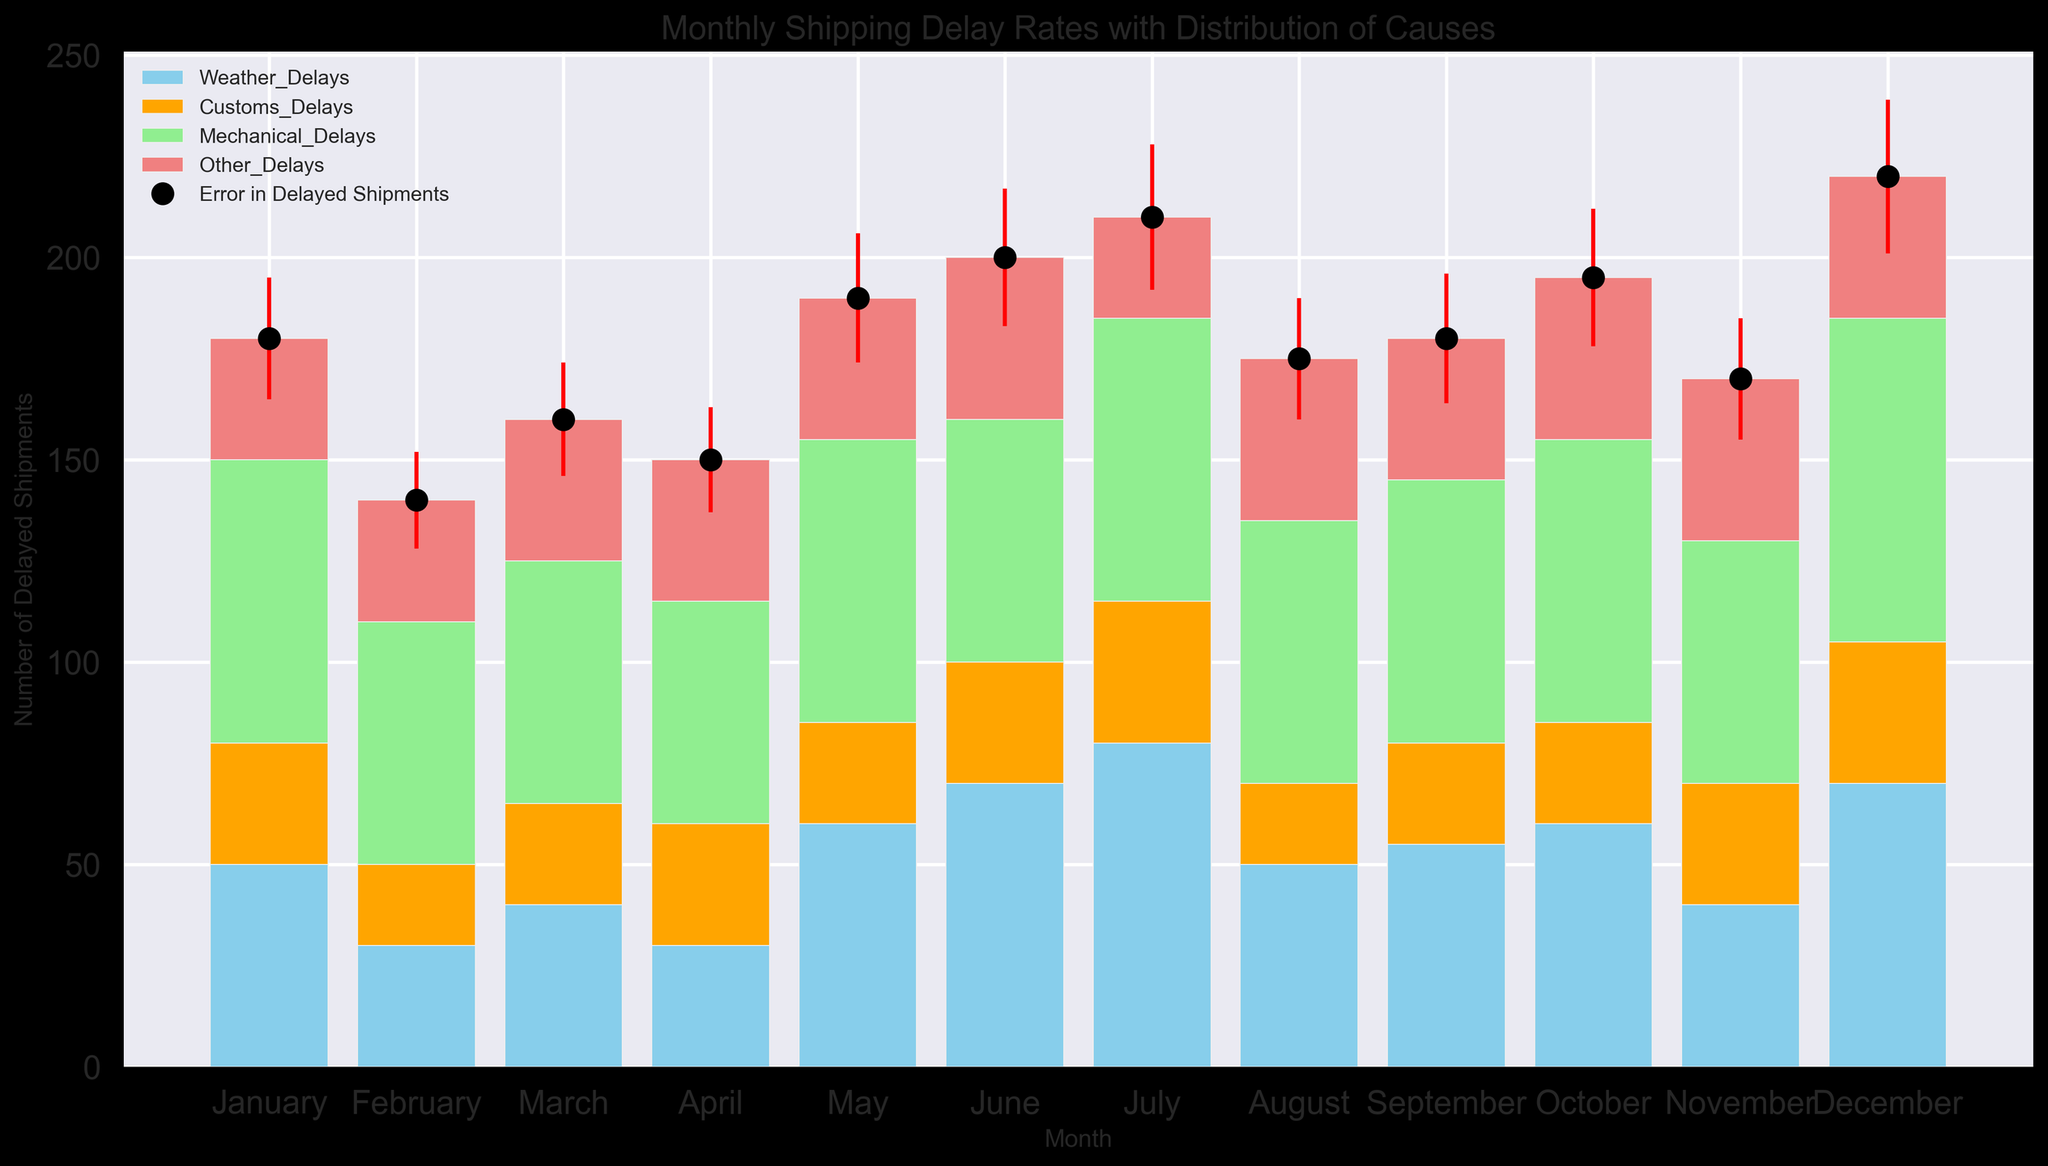What month had the highest number of delayed shipments? By looking at the height of the bars and the values of the delayed shipments, we can see that December has the highest number of delayed shipments.
Answer: December Which cause contributed the most to the delays in July? By examining the height of the segments in July's bar and their colors, we see the largest segment is light green, which corresponds to Mechanical Delays.
Answer: Mechanical Delays How many total delays were there in March, combining all causes? Summing up all delays for March: 40 (Weather) + 25 (Customs) + 60 (Mechanical) + 35 (Other).
Answer: 160 Which month had the largest error in delayed shipments? By observing the lengths of the error lines (red) on the plot, we see December has the longest error bar.
Answer: December How do the weather delays in June compare to those in January? By comparing the height of the sky blue segments for January and June, June has a higher segment (70) than January (50).
Answer: June has more weather delays Calculate the average number of delayed shipments from February to April. Summing the delayed shipments: 140 (Feb) + 160 (Mar) + 150 (Apr) = 450, then dividing by 3 months.
Answer: 150 In which months did Mechanical Delays exceed 60 shipments? Observing the light green segments for months, we find that January (70), March (60), May (70), June (60), July (70), October (70), and December (80) are the months where Mechanical Delays exceeded or equaled 60.
Answer: January, May, July, October, December Did Customs Delays ever exceed 35 shipments in any month? Checking the height of the orange segments (Customs Delays) in all months, they never exceed 35 shipments.
Answer: No By how much did the total delays in August exceed those in September? Total delays in August were 175, while in September they were 180. August did not exceed but rather shipped fewer compared to September. We find the difference by calculating 180 - 175.
Answer: 5 fewer in August On average, how many other types of delays were there per month? Summing Other Delays: 30 + 30 + 35 + 35 + 35 + 40 + 25 + 40 + 35 + 40 + 40 + 35 = 420, then dividing by 12 months.
Answer: 35 